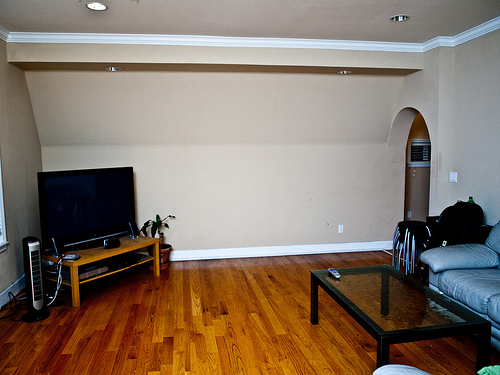<image>
Is the tv on the wall? No. The tv is not positioned on the wall. They may be near each other, but the tv is not supported by or resting on top of the wall. 